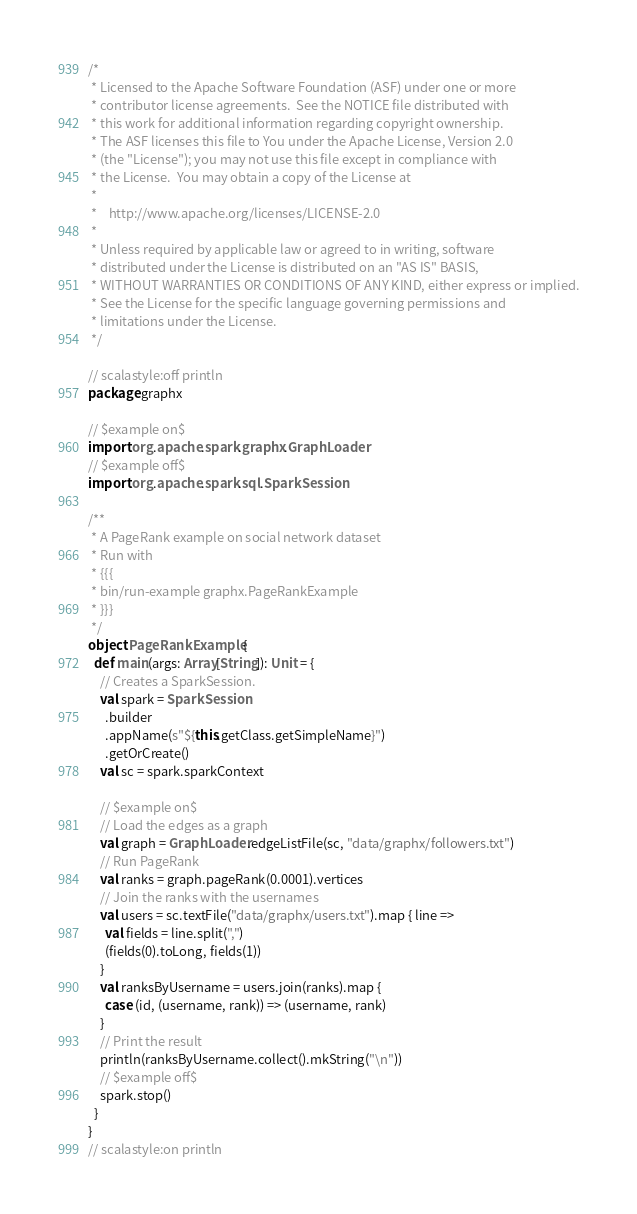Convert code to text. <code><loc_0><loc_0><loc_500><loc_500><_Scala_>/*
 * Licensed to the Apache Software Foundation (ASF) under one or more
 * contributor license agreements.  See the NOTICE file distributed with
 * this work for additional information regarding copyright ownership.
 * The ASF licenses this file to You under the Apache License, Version 2.0
 * (the "License"); you may not use this file except in compliance with
 * the License.  You may obtain a copy of the License at
 *
 *    http://www.apache.org/licenses/LICENSE-2.0
 *
 * Unless required by applicable law or agreed to in writing, software
 * distributed under the License is distributed on an "AS IS" BASIS,
 * WITHOUT WARRANTIES OR CONDITIONS OF ANY KIND, either express or implied.
 * See the License for the specific language governing permissions and
 * limitations under the License.
 */

// scalastyle:off println
package graphx

// $example on$
import org.apache.spark.graphx.GraphLoader
// $example off$
import org.apache.spark.sql.SparkSession

/**
 * A PageRank example on social network dataset
 * Run with
 * {{{
 * bin/run-example graphx.PageRankExample
 * }}}
 */
object PageRankExample {
  def main(args: Array[String]): Unit = {
    // Creates a SparkSession.
    val spark = SparkSession
      .builder
      .appName(s"${this.getClass.getSimpleName}")
      .getOrCreate()
    val sc = spark.sparkContext

    // $example on$
    // Load the edges as a graph
    val graph = GraphLoader.edgeListFile(sc, "data/graphx/followers.txt")
    // Run PageRank
    val ranks = graph.pageRank(0.0001).vertices
    // Join the ranks with the usernames
    val users = sc.textFile("data/graphx/users.txt").map { line =>
      val fields = line.split(",")
      (fields(0).toLong, fields(1))
    }
    val ranksByUsername = users.join(ranks).map {
      case (id, (username, rank)) => (username, rank)
    }
    // Print the result
    println(ranksByUsername.collect().mkString("\n"))
    // $example off$
    spark.stop()
  }
}
// scalastyle:on println
</code> 